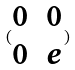Convert formula to latex. <formula><loc_0><loc_0><loc_500><loc_500>( \begin{matrix} 0 & 0 \\ 0 & e \end{matrix} )</formula> 